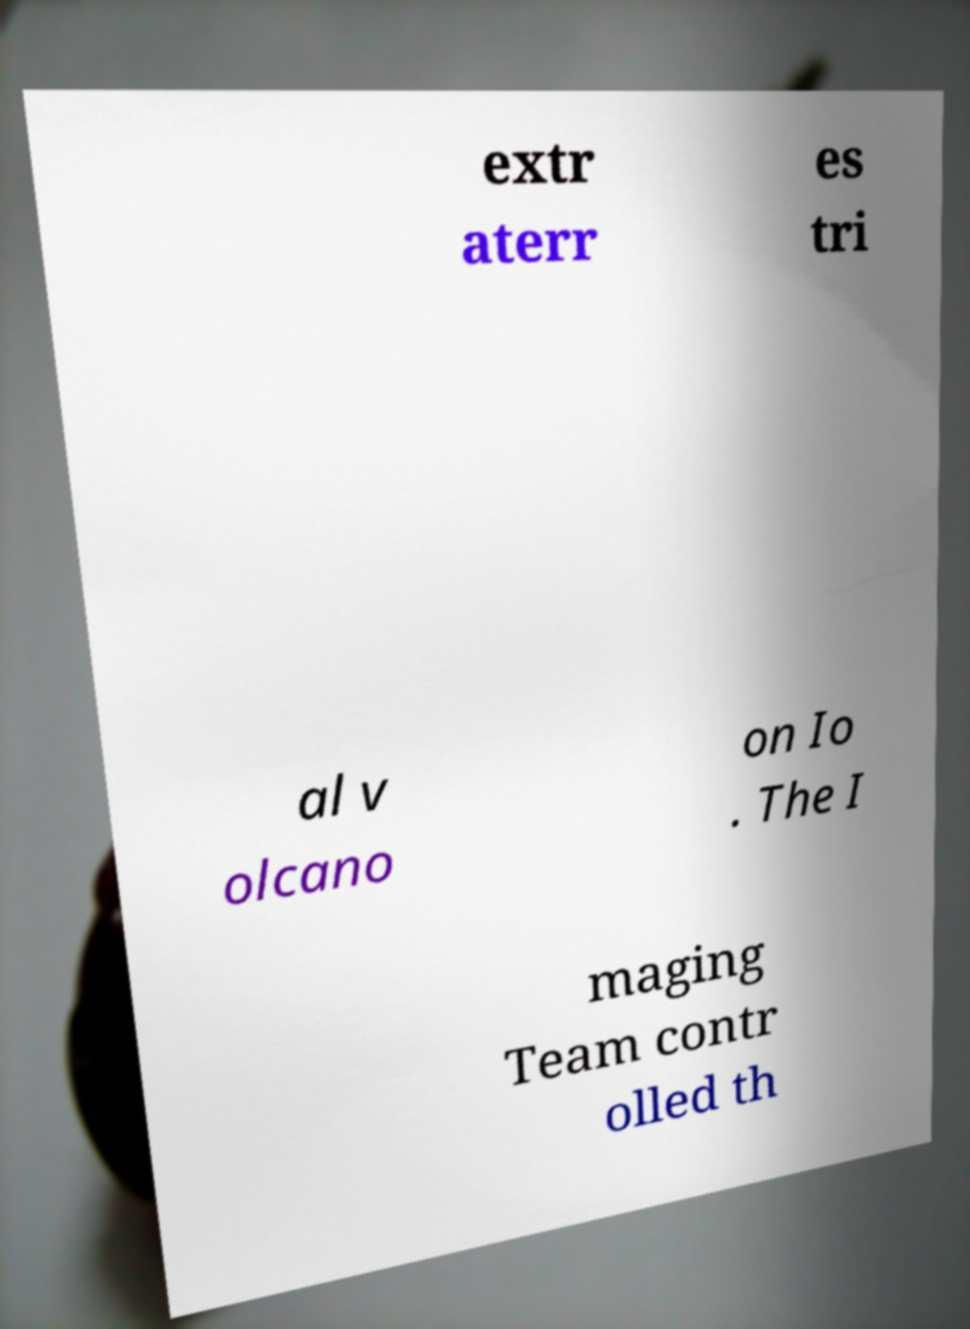Can you read and provide the text displayed in the image?This photo seems to have some interesting text. Can you extract and type it out for me? extr aterr es tri al v olcano on Io . The I maging Team contr olled th 